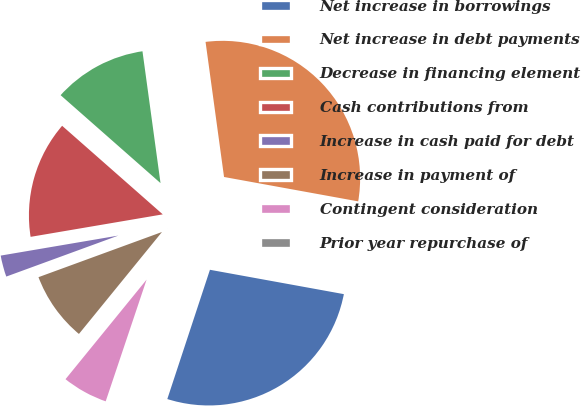Convert chart to OTSL. <chart><loc_0><loc_0><loc_500><loc_500><pie_chart><fcel>Net increase in borrowings<fcel>Net increase in debt payments<fcel>Decrease in financing element<fcel>Cash contributions from<fcel>Increase in cash paid for debt<fcel>Increase in payment of<fcel>Contingent consideration<fcel>Prior year repurchase of<nl><fcel>27.21%<fcel>30.03%<fcel>11.35%<fcel>14.17%<fcel>2.9%<fcel>8.54%<fcel>5.72%<fcel>0.09%<nl></chart> 